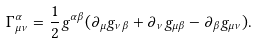<formula> <loc_0><loc_0><loc_500><loc_500>\Gamma ^ { \alpha } _ { \mu \nu } = \frac { 1 } { 2 } g ^ { \alpha \beta } ( \partial _ { \mu } g _ { \nu \beta } + \partial _ { \nu } g _ { \mu \beta } - \partial _ { \beta } g _ { \mu \nu } ) .</formula> 